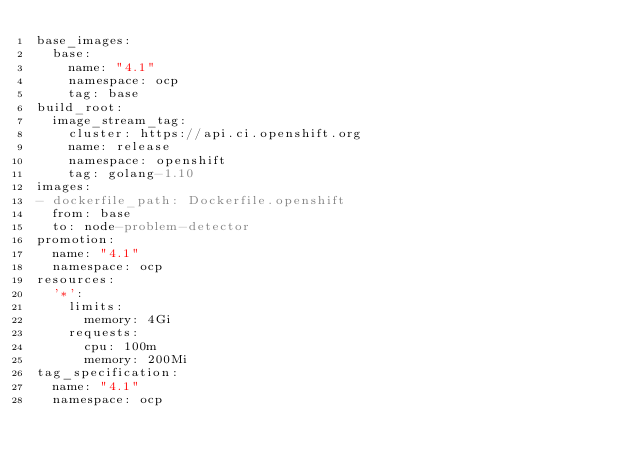<code> <loc_0><loc_0><loc_500><loc_500><_YAML_>base_images:
  base:
    name: "4.1"
    namespace: ocp
    tag: base
build_root:
  image_stream_tag:
    cluster: https://api.ci.openshift.org
    name: release
    namespace: openshift
    tag: golang-1.10
images:
- dockerfile_path: Dockerfile.openshift
  from: base
  to: node-problem-detector
promotion:
  name: "4.1"
  namespace: ocp
resources:
  '*':
    limits:
      memory: 4Gi
    requests:
      cpu: 100m
      memory: 200Mi
tag_specification:
  name: "4.1"
  namespace: ocp
</code> 